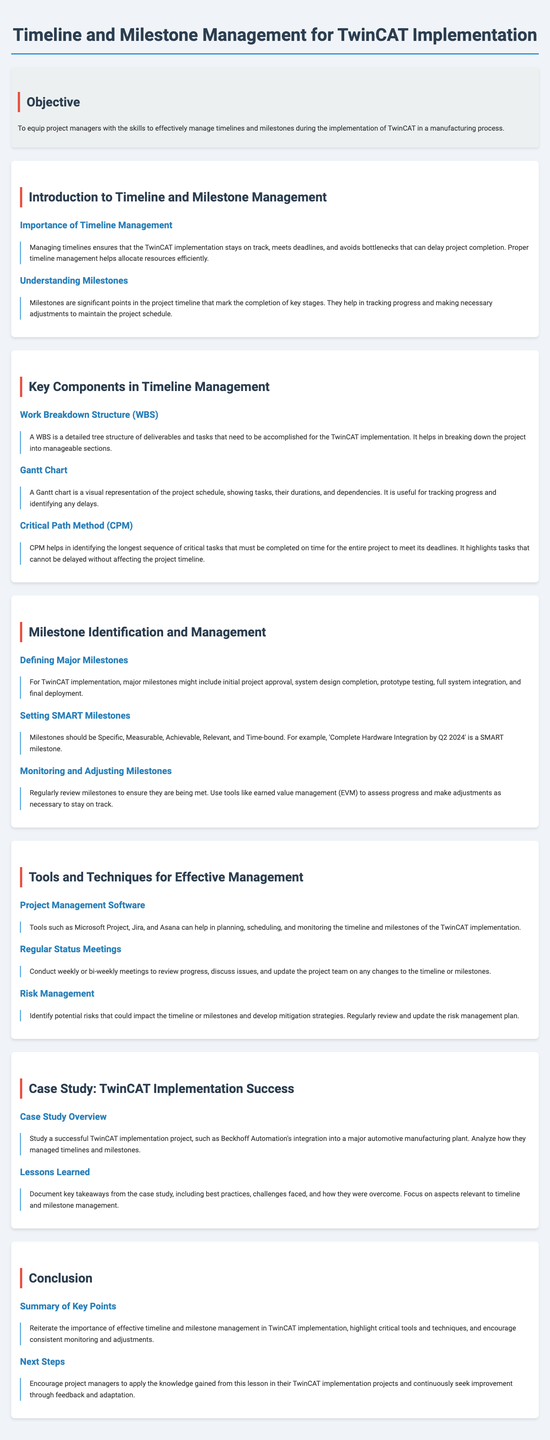What is the objective of the lesson? The objective is outlined in the objective section of the document, focusing on equipping project managers with skills for timeline and milestone management during TwinCAT implementation.
Answer: To equip project managers with the skills to effectively manage timelines and milestones during the implementation of TwinCAT in a manufacturing process What is a major milestone in TwinCAT implementation? Major milestones are discussed under the section about milestone identification and management, including various key stages of the project.
Answer: Initial project approval, system design completion, prototype testing, full system integration, and final deployment What does WBS stand for? WBS is mentioned in the key components of timeline management, where it is defined for the TwinCAT implementation process.
Answer: Work Breakdown Structure What is a Gantt chart used for? The purpose of a Gantt chart is explained in the document concerning its function in project scheduling and tracking.
Answer: To track progress and identify delays Which software can help in managing the timeline of TwinCAT implementation? The document lists various project management software tools in the tools and techniques section that can assist with planning and monitoring.
Answer: Microsoft Project, Jira, and Asana What does SMART stand for regarding milestones? The explanation of SMART milestones includes criteria that each milestone should meet for effective management.
Answer: Specific, Measurable, Achievable, Relevant, and Time-bound What is the critical path method? The critical path method is explained in the key components section, relating to its importance in identifying task sequences necessary for timely project completion.
Answer: To identify the longest sequence of critical tasks that must be completed on time What should project managers do in the next steps? The conclusion section provides guidance on actions project managers should take following the lesson.
Answer: Apply the knowledge gained from this lesson in their TwinCAT implementation projects and continuously seek improvement through feedback and adaptation What was a focus in the case study section? The case study section discusses elements like successful project implementation for TwinCAT in a specific industry, which highlights its application in real-world scenarios.
Answer: Management of timelines and milestones 